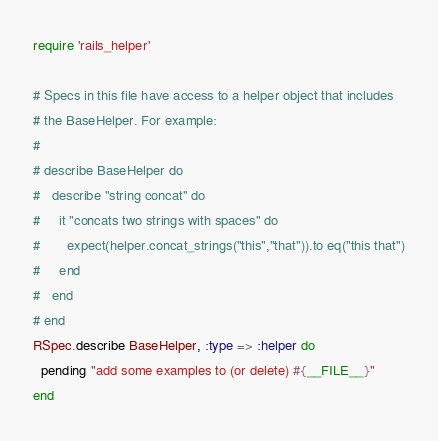<code> <loc_0><loc_0><loc_500><loc_500><_Ruby_>require 'rails_helper'

# Specs in this file have access to a helper object that includes
# the BaseHelper. For example:
#
# describe BaseHelper do
#   describe "string concat" do
#     it "concats two strings with spaces" do
#       expect(helper.concat_strings("this","that")).to eq("this that")
#     end
#   end
# end
RSpec.describe BaseHelper, :type => :helper do
  pending "add some examples to (or delete) #{__FILE__}"
end
</code> 